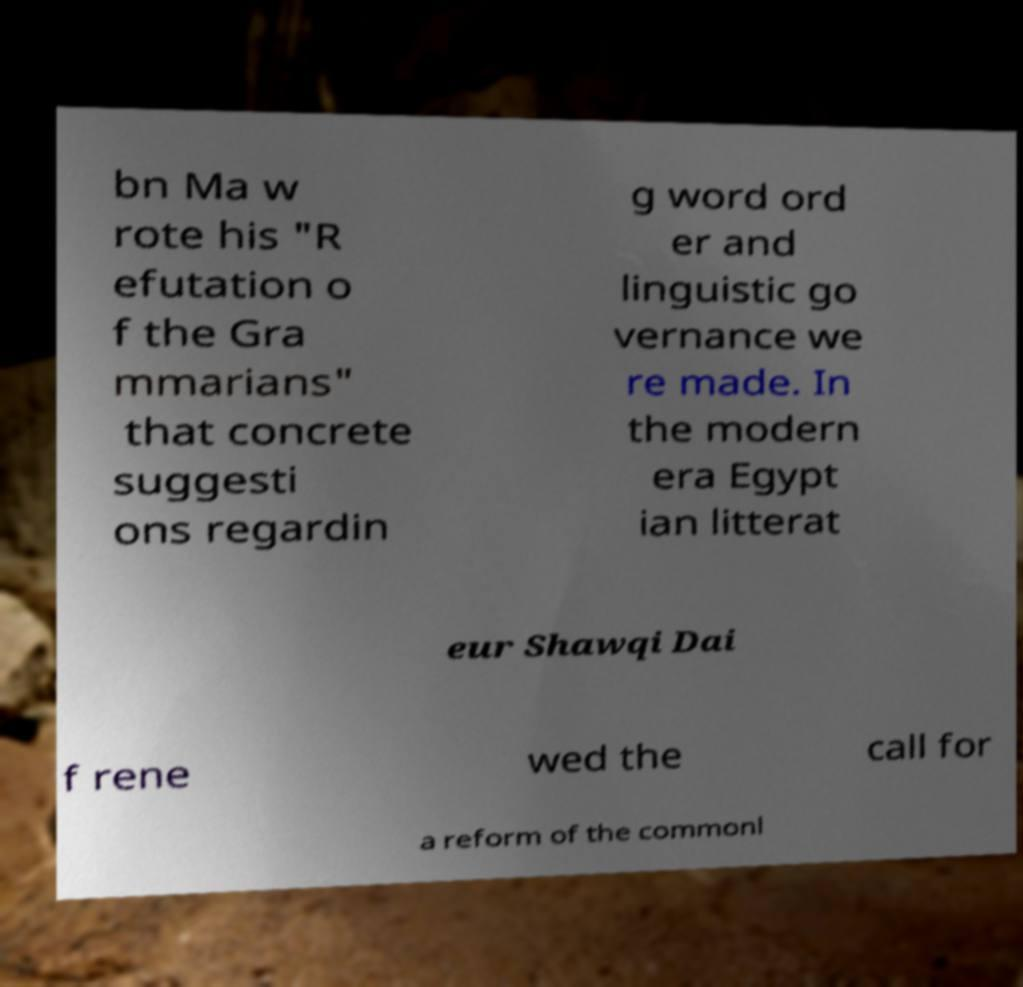For documentation purposes, I need the text within this image transcribed. Could you provide that? bn Ma w rote his "R efutation o f the Gra mmarians" that concrete suggesti ons regardin g word ord er and linguistic go vernance we re made. In the modern era Egypt ian litterat eur Shawqi Dai f rene wed the call for a reform of the commonl 